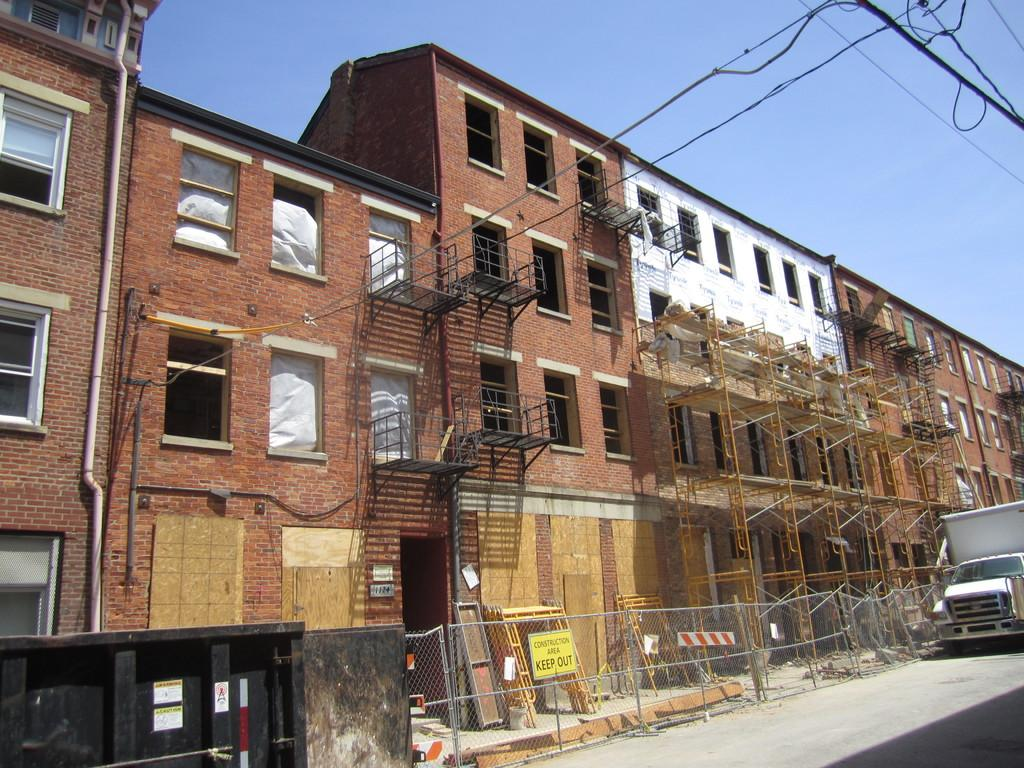What is the color of the building in the image? The building in the image is brown-colored. What can be seen on the road in the image? There is a vehicle on the road in the image. What is the purpose of the railing in the image? The railing in the image is likely for safety or to prevent people from falling. What is the color of the sky in the image? The sky is blue in the image. What type of grain is being harvested in the image? There is no grain or harvesting activity present in the image. What reason does the vehicle have for being on the road in the image? The reason for the vehicle being on the road in the image cannot be determined from the image alone. 